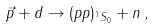Convert formula to latex. <formula><loc_0><loc_0><loc_500><loc_500>\vec { p } + d \to ( p p ) _ { ^ { 1 } S _ { 0 } } + n \, ,</formula> 